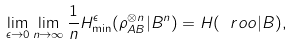<formula> <loc_0><loc_0><loc_500><loc_500>\lim _ { \epsilon \rightarrow 0 } \lim _ { n \rightarrow \infty } \frac { 1 } { n } H _ { \min } ^ { \epsilon } ( \rho _ { A B } ^ { \otimes n } | B ^ { n } ) = H ( \ r o o | B ) ,</formula> 